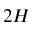<formula> <loc_0><loc_0><loc_500><loc_500>2 H</formula> 